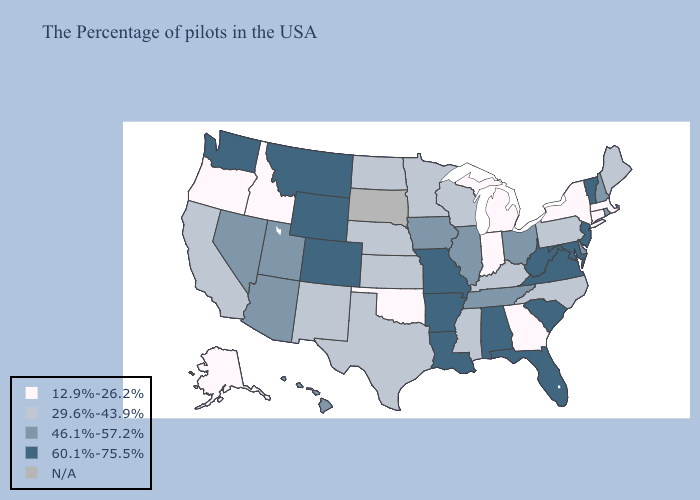What is the value of Idaho?
Answer briefly. 12.9%-26.2%. Name the states that have a value in the range N/A?
Quick response, please. South Dakota. Name the states that have a value in the range N/A?
Quick response, please. South Dakota. Does Colorado have the lowest value in the West?
Write a very short answer. No. Among the states that border Missouri , which have the lowest value?
Short answer required. Oklahoma. What is the value of Nebraska?
Answer briefly. 29.6%-43.9%. Name the states that have a value in the range 29.6%-43.9%?
Keep it brief. Maine, Pennsylvania, North Carolina, Kentucky, Wisconsin, Mississippi, Minnesota, Kansas, Nebraska, Texas, North Dakota, New Mexico, California. Which states have the lowest value in the USA?
Be succinct. Massachusetts, Connecticut, New York, Georgia, Michigan, Indiana, Oklahoma, Idaho, Oregon, Alaska. What is the lowest value in states that border Kentucky?
Give a very brief answer. 12.9%-26.2%. What is the value of Montana?
Keep it brief. 60.1%-75.5%. Does the map have missing data?
Quick response, please. Yes. What is the highest value in the USA?
Concise answer only. 60.1%-75.5%. Name the states that have a value in the range 12.9%-26.2%?
Write a very short answer. Massachusetts, Connecticut, New York, Georgia, Michigan, Indiana, Oklahoma, Idaho, Oregon, Alaska. Does Vermont have the highest value in the USA?
Answer briefly. Yes. Does the map have missing data?
Keep it brief. Yes. 